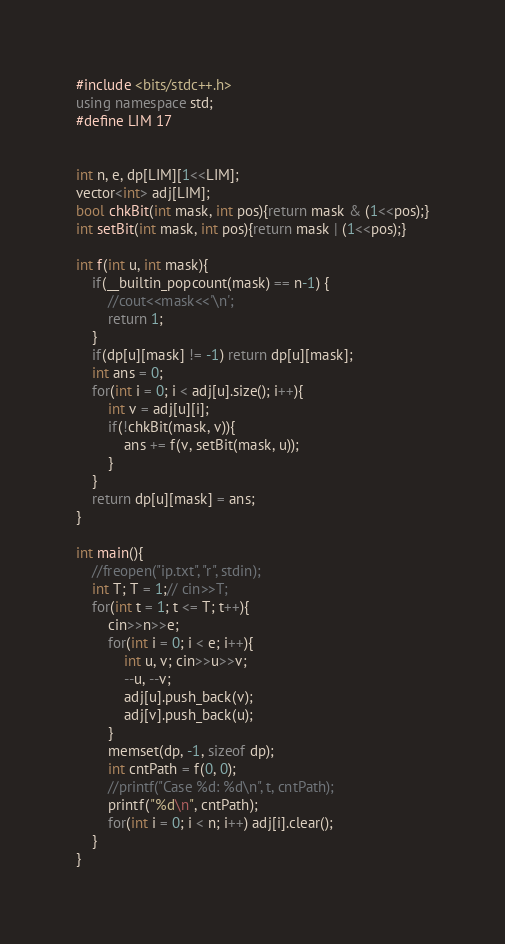Convert code to text. <code><loc_0><loc_0><loc_500><loc_500><_C++_>#include <bits/stdc++.h>
using namespace std;
#define LIM 17


int n, e, dp[LIM][1<<LIM];
vector<int> adj[LIM];
bool chkBit(int mask, int pos){return mask & (1<<pos);}
int setBit(int mask, int pos){return mask | (1<<pos);}

int f(int u, int mask){
    if(__builtin_popcount(mask) == n-1) {
        //cout<<mask<<'\n';
        return 1;
    }
    if(dp[u][mask] != -1) return dp[u][mask];
    int ans = 0;
    for(int i = 0; i < adj[u].size(); i++){
        int v = adj[u][i];
        if(!chkBit(mask, v)){
            ans += f(v, setBit(mask, u));
        }
    }
    return dp[u][mask] = ans;
}

int main(){
    //freopen("ip.txt", "r", stdin);
    int T; T = 1;// cin>>T;
    for(int t = 1; t <= T; t++){
        cin>>n>>e;
        for(int i = 0; i < e; i++){
            int u, v; cin>>u>>v;
            --u, --v;
            adj[u].push_back(v);
            adj[v].push_back(u);
        }
        memset(dp, -1, sizeof dp);
        int cntPath = f(0, 0);
        //printf("Case %d: %d\n", t, cntPath);
        printf("%d\n", cntPath);
        for(int i = 0; i < n; i++) adj[i].clear();
    }
}
</code> 